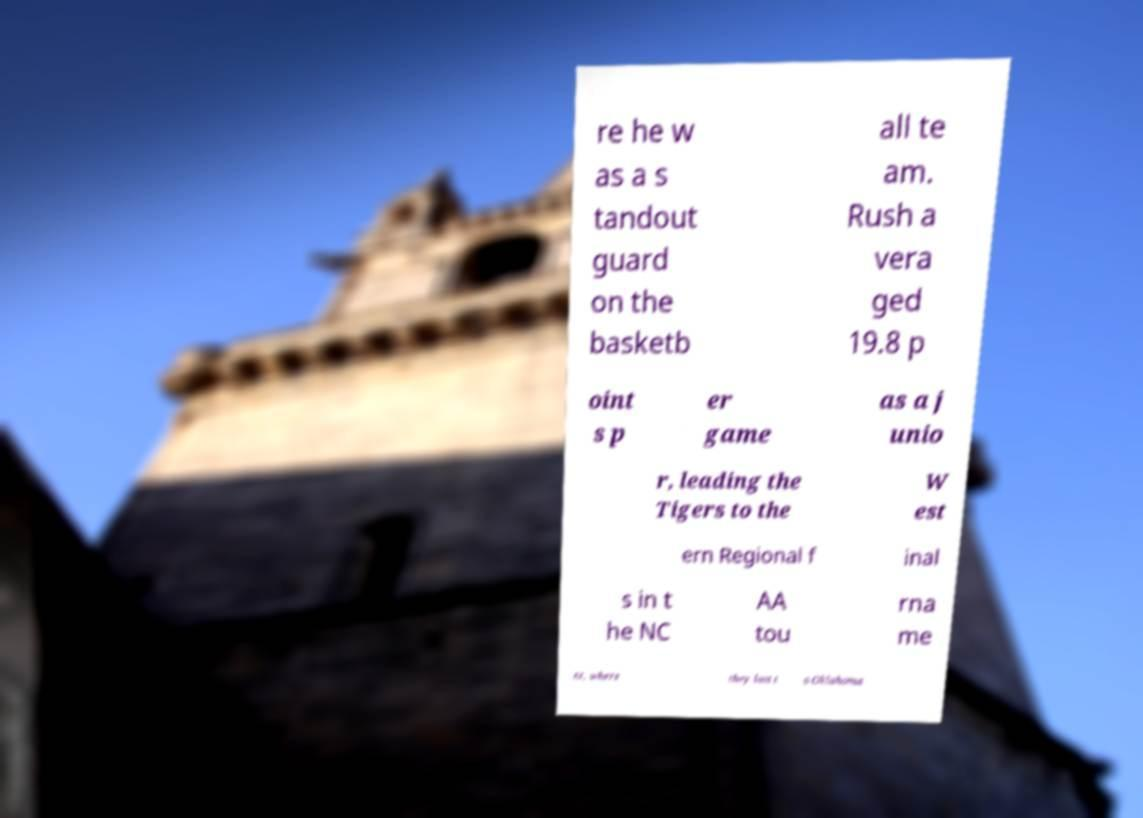Please read and relay the text visible in this image. What does it say? re he w as a s tandout guard on the basketb all te am. Rush a vera ged 19.8 p oint s p er game as a j unio r, leading the Tigers to the W est ern Regional f inal s in t he NC AA tou rna me nt, where they lost t o Oklahoma 